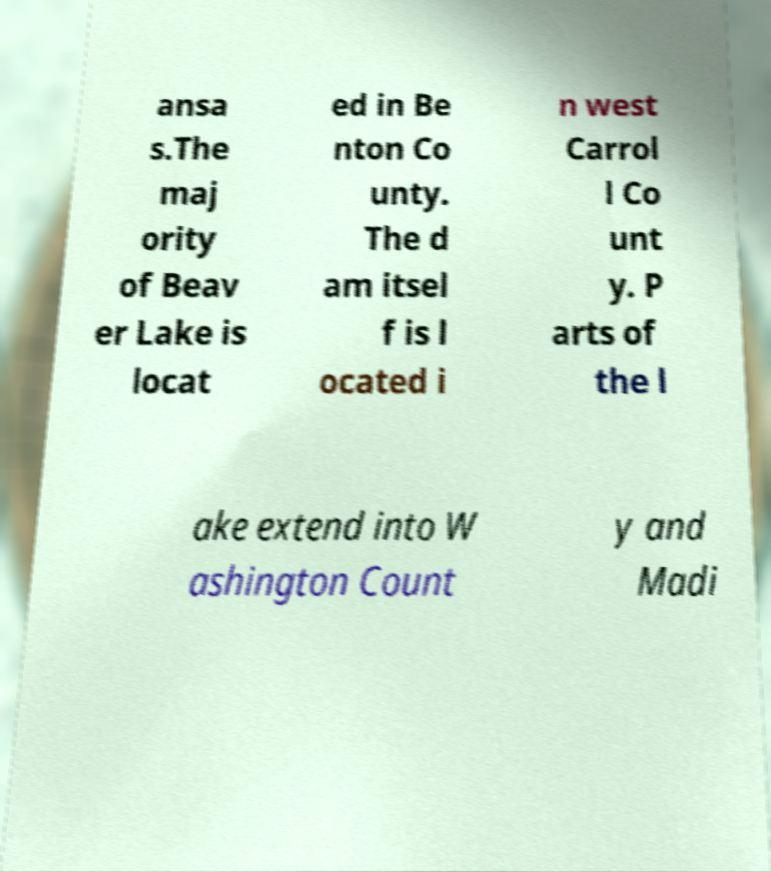Please read and relay the text visible in this image. What does it say? ansa s.The maj ority of Beav er Lake is locat ed in Be nton Co unty. The d am itsel f is l ocated i n west Carrol l Co unt y. P arts of the l ake extend into W ashington Count y and Madi 